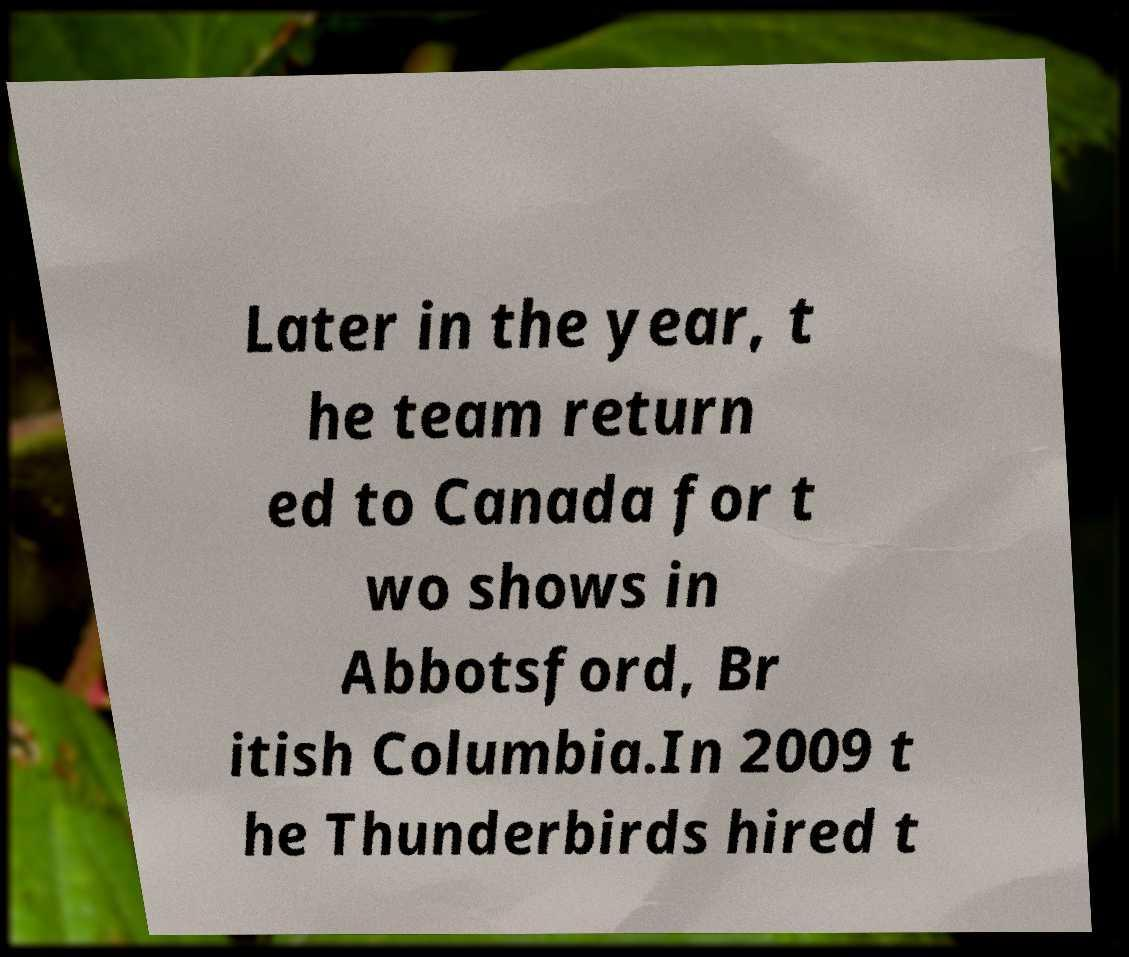For documentation purposes, I need the text within this image transcribed. Could you provide that? Later in the year, t he team return ed to Canada for t wo shows in Abbotsford, Br itish Columbia.In 2009 t he Thunderbirds hired t 